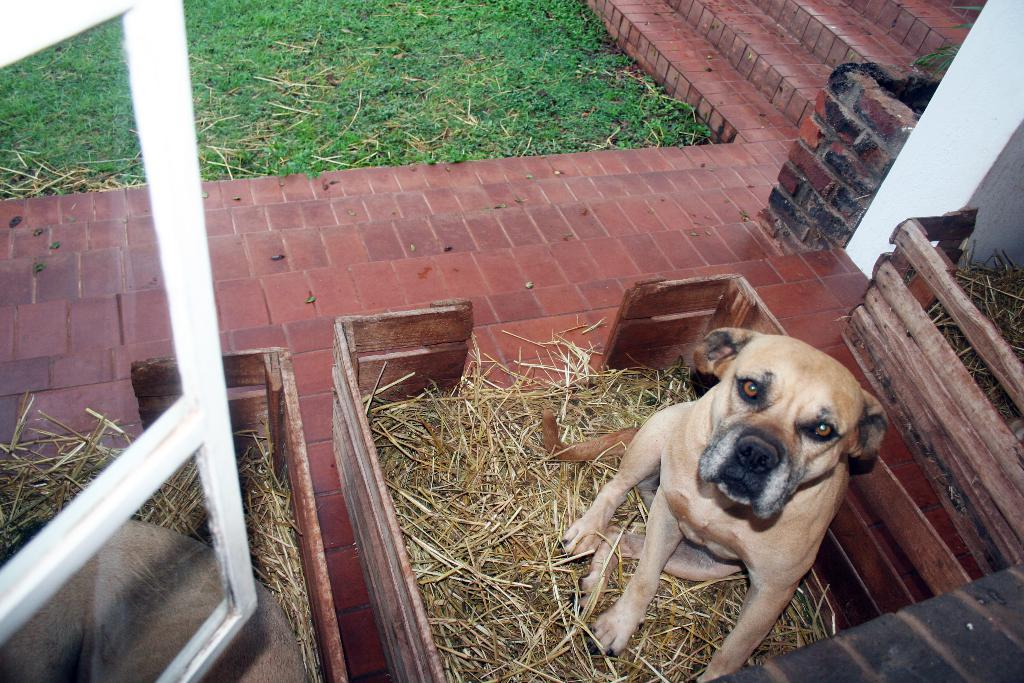How many wooden boxes are in the image? There are three wooden boxes in the image. What is on top of the center box? A dog is sitting on the center box. Where is the dog sitting? The dog is sitting on the center box, which is on grass. What is the floor made of? The floor is made of bricks. What type of vegetation is present in the image? There are grasses in the image. What is the dog's opinion on honey in the image? There is no indication of the dog's opinion on honey in the image, as it does not involve any interaction with honey. Can you see the dog skating on the grass in the image? No, the dog is sitting on the wooden box, not skating on the grass. 